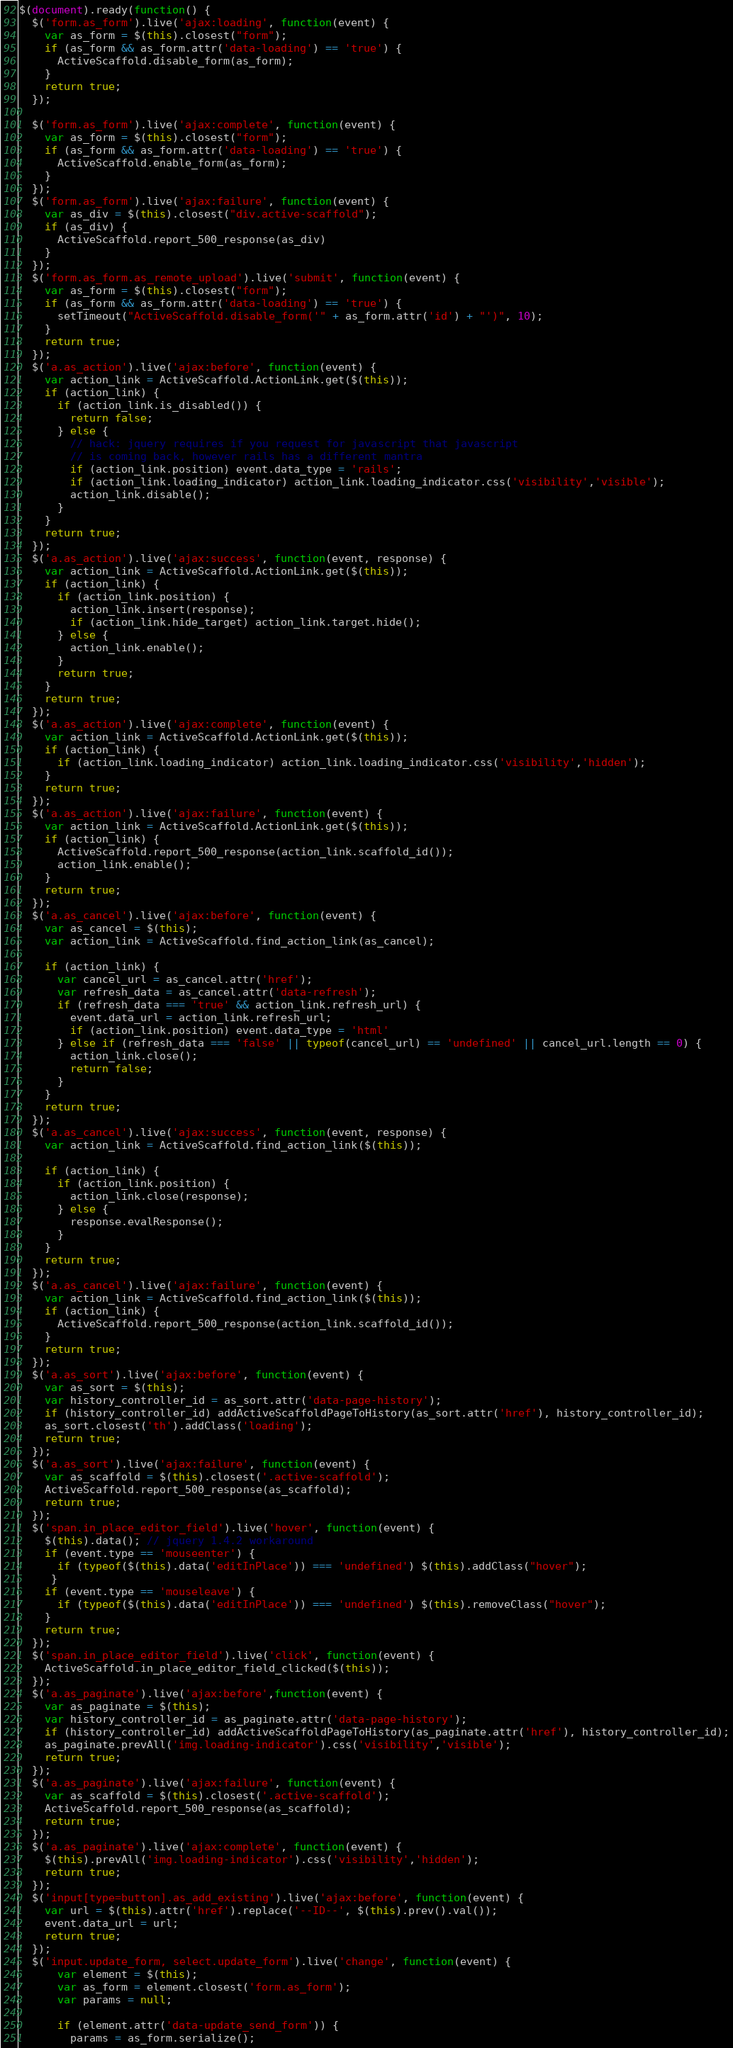<code> <loc_0><loc_0><loc_500><loc_500><_JavaScript_>$(document).ready(function() {
  $('form.as_form').live('ajax:loading', function(event) {
    var as_form = $(this).closest("form");
    if (as_form && as_form.attr('data-loading') == 'true') {
      ActiveScaffold.disable_form(as_form);
    }
    return true;
  });
  
  $('form.as_form').live('ajax:complete', function(event) {
    var as_form = $(this).closest("form");
    if (as_form && as_form.attr('data-loading') == 'true') {
      ActiveScaffold.enable_form(as_form);
    }
  });
  $('form.as_form').live('ajax:failure', function(event) {
    var as_div = $(this).closest("div.active-scaffold");
    if (as_div) {
      ActiveScaffold.report_500_response(as_div)
    }
  });
  $('form.as_form.as_remote_upload').live('submit', function(event) {
    var as_form = $(this).closest("form");
    if (as_form && as_form.attr('data-loading') == 'true') {
      setTimeout("ActiveScaffold.disable_form('" + as_form.attr('id') + "')", 10);
    }
    return true;
  });
  $('a.as_action').live('ajax:before', function(event) {
    var action_link = ActiveScaffold.ActionLink.get($(this));
    if (action_link) {
      if (action_link.is_disabled()) {
        return false;
      } else {
        // hack: jquery requires if you request for javascript that javascript
        // is coming back, however rails has a different mantra
        if (action_link.position) event.data_type = 'rails';
        if (action_link.loading_indicator) action_link.loading_indicator.css('visibility','visible');
        action_link.disable();
      }
    }
    return true;
  });
  $('a.as_action').live('ajax:success', function(event, response) {
    var action_link = ActiveScaffold.ActionLink.get($(this));
    if (action_link) {
      if (action_link.position) {
        action_link.insert(response);
        if (action_link.hide_target) action_link.target.hide();
      } else {
        action_link.enable();
      }
      return true;
    }
    return true;
  });
  $('a.as_action').live('ajax:complete', function(event) {
    var action_link = ActiveScaffold.ActionLink.get($(this));
    if (action_link) {
      if (action_link.loading_indicator) action_link.loading_indicator.css('visibility','hidden');  
    }
    return true;
  });
  $('a.as_action').live('ajax:failure', function(event) {
    var action_link = ActiveScaffold.ActionLink.get($(this));
    if (action_link) {
      ActiveScaffold.report_500_response(action_link.scaffold_id());
      action_link.enable();
    }
    return true;
  });
  $('a.as_cancel').live('ajax:before', function(event) {
    var as_cancel = $(this);
    var action_link = ActiveScaffold.find_action_link(as_cancel);  
    
    if (action_link) {
      var cancel_url = as_cancel.attr('href');
      var refresh_data = as_cancel.attr('data-refresh');
      if (refresh_data === 'true' && action_link.refresh_url) {
        event.data_url = action_link.refresh_url;
        if (action_link.position) event.data_type = 'html' 
      } else if (refresh_data === 'false' || typeof(cancel_url) == 'undefined' || cancel_url.length == 0) {
        action_link.close();
        return false;
      }
    }
    return true;
  });
  $('a.as_cancel').live('ajax:success', function(event, response) {
    var action_link = ActiveScaffold.find_action_link($(this));

    if (action_link) {
      if (action_link.position) {
        action_link.close(response);
      } else {
        response.evalResponse(); 
      }
    }
    return true;
  });
  $('a.as_cancel').live('ajax:failure', function(event) {
    var action_link = ActiveScaffold.find_action_link($(this));
    if (action_link) {
      ActiveScaffold.report_500_response(action_link.scaffold_id());
    }
    return true;
  });
  $('a.as_sort').live('ajax:before', function(event) {
    var as_sort = $(this);
    var history_controller_id = as_sort.attr('data-page-history');
    if (history_controller_id) addActiveScaffoldPageToHistory(as_sort.attr('href'), history_controller_id);
    as_sort.closest('th').addClass('loading');
    return true;
  });
  $('a.as_sort').live('ajax:failure', function(event) {
    var as_scaffold = $(this).closest('.active-scaffold');
    ActiveScaffold.report_500_response(as_scaffold);
    return true;
  });
  $('span.in_place_editor_field').live('hover', function(event) {
    $(this).data(); // jquery 1.4.2 workaround
    if (event.type == 'mouseenter') {
      if (typeof($(this).data('editInPlace')) === 'undefined') $(this).addClass("hover");
     }
    if (event.type == 'mouseleave') {
      if (typeof($(this).data('editInPlace')) === 'undefined') $(this).removeClass("hover");
    }
    return true;
  });
  $('span.in_place_editor_field').live('click', function(event) {
    ActiveScaffold.in_place_editor_field_clicked($(this));
  });
  $('a.as_paginate').live('ajax:before',function(event) {
    var as_paginate = $(this);
    var history_controller_id = as_paginate.attr('data-page-history');
    if (history_controller_id) addActiveScaffoldPageToHistory(as_paginate.attr('href'), history_controller_id);
    as_paginate.prevAll('img.loading-indicator').css('visibility','visible');
    return true;
  });
  $('a.as_paginate').live('ajax:failure', function(event) {
    var as_scaffold = $(this).closest('.active-scaffold');
    ActiveScaffold.report_500_response(as_scaffold);
    return true;
  });
  $('a.as_paginate').live('ajax:complete', function(event) {
    $(this).prevAll('img.loading-indicator').css('visibility','hidden');
    return true;
  });
  $('input[type=button].as_add_existing').live('ajax:before', function(event) {
    var url = $(this).attr('href').replace('--ID--', $(this).prev().val());
    event.data_url = url;
    return true;
  });
  $('input.update_form, select.update_form').live('change', function(event) {
      var element = $(this);
      var as_form = element.closest('form.as_form');
      var params = null;

      if (element.attr('data-update_send_form')) {
        params = as_form.serialize();</code> 